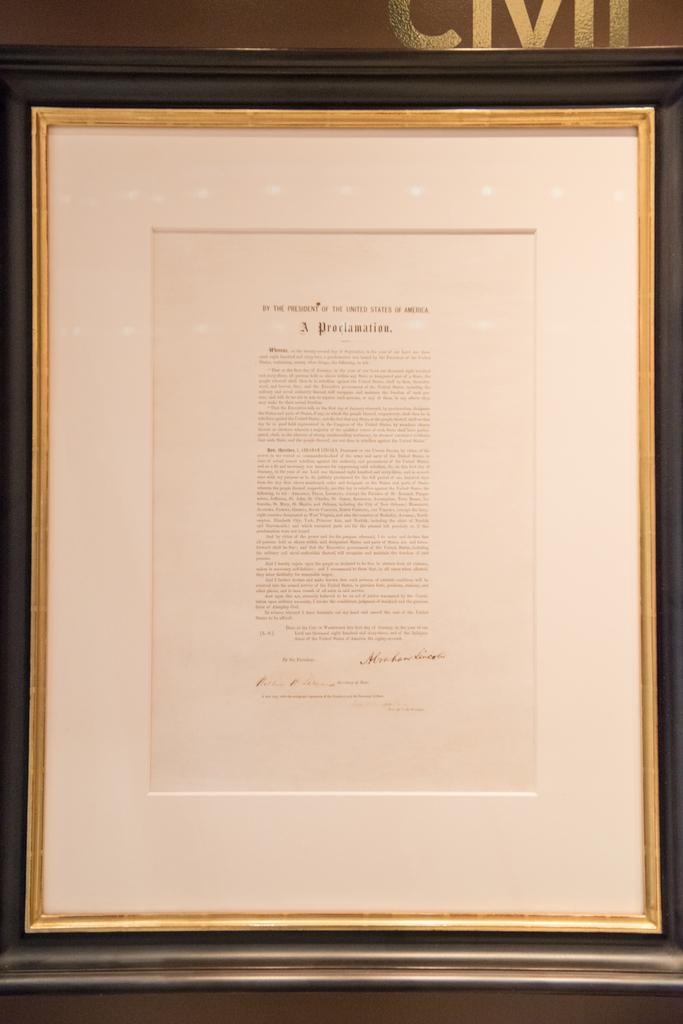<image>
Render a clear and concise summary of the photo. a document with a proclamation at the top of it 